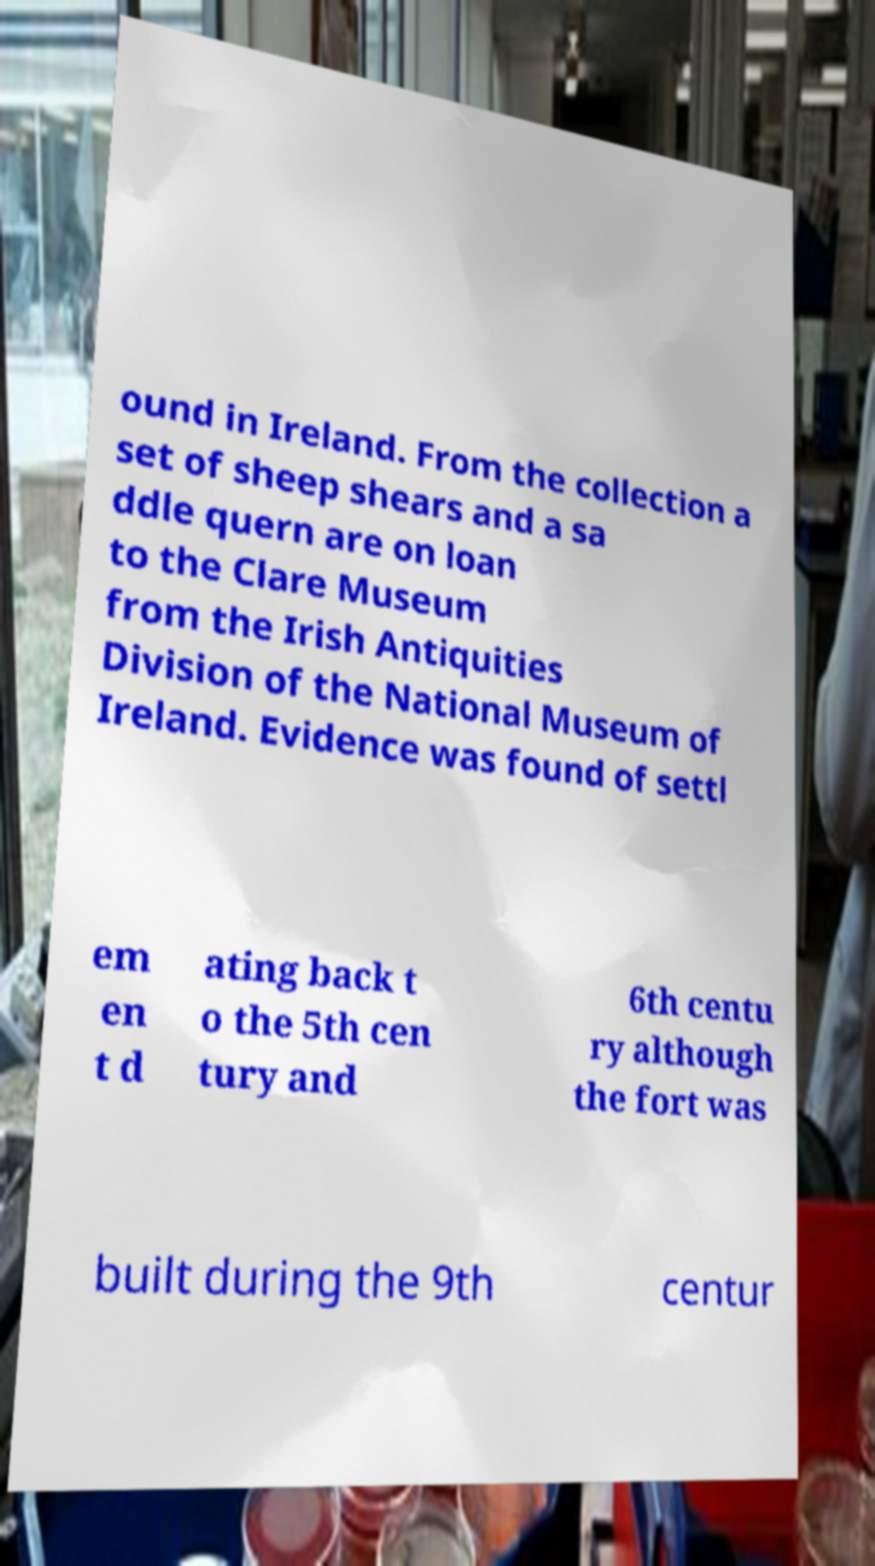There's text embedded in this image that I need extracted. Can you transcribe it verbatim? ound in Ireland. From the collection a set of sheep shears and a sa ddle quern are on loan to the Clare Museum from the Irish Antiquities Division of the National Museum of Ireland. Evidence was found of settl em en t d ating back t o the 5th cen tury and 6th centu ry although the fort was built during the 9th centur 